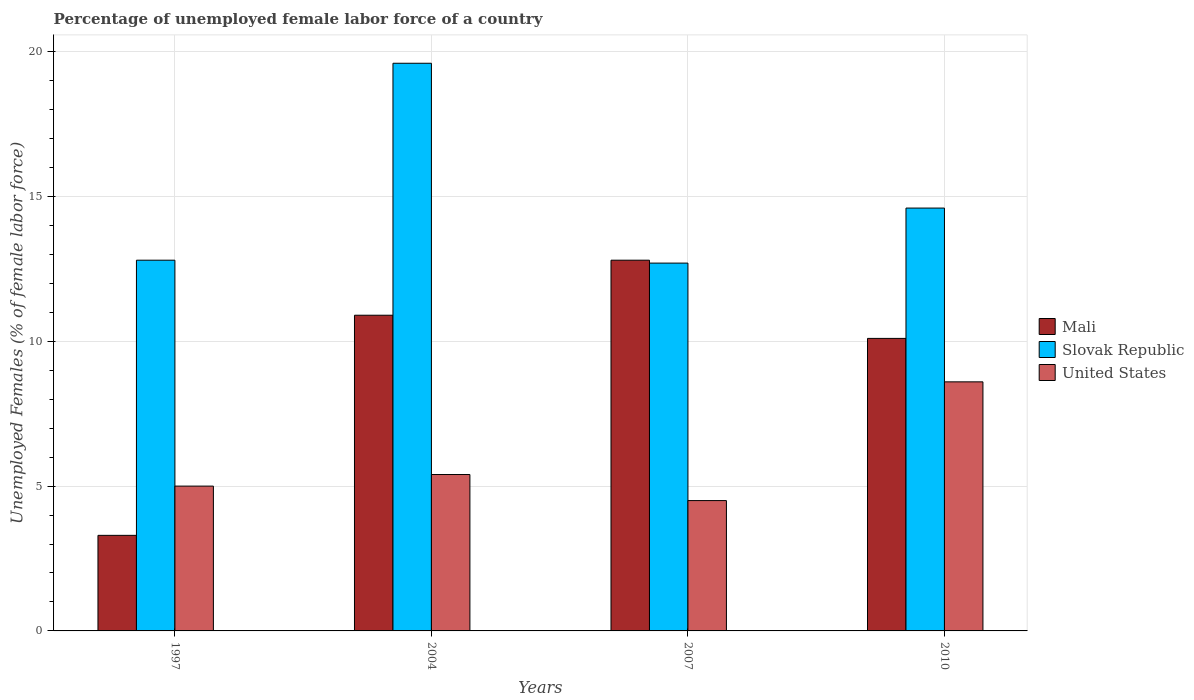How many different coloured bars are there?
Keep it short and to the point. 3. Are the number of bars on each tick of the X-axis equal?
Provide a short and direct response. Yes. How many bars are there on the 2nd tick from the right?
Offer a terse response. 3. What is the label of the 3rd group of bars from the left?
Your answer should be compact. 2007. What is the percentage of unemployed female labor force in United States in 2007?
Provide a short and direct response. 4.5. Across all years, what is the maximum percentage of unemployed female labor force in United States?
Offer a terse response. 8.6. In which year was the percentage of unemployed female labor force in Slovak Republic minimum?
Keep it short and to the point. 2007. What is the total percentage of unemployed female labor force in Slovak Republic in the graph?
Provide a short and direct response. 59.7. What is the difference between the percentage of unemployed female labor force in United States in 1997 and that in 2010?
Offer a terse response. -3.6. What is the average percentage of unemployed female labor force in Mali per year?
Keep it short and to the point. 9.28. In the year 2004, what is the difference between the percentage of unemployed female labor force in United States and percentage of unemployed female labor force in Mali?
Your answer should be very brief. -5.5. In how many years, is the percentage of unemployed female labor force in United States greater than 8 %?
Your response must be concise. 1. What is the ratio of the percentage of unemployed female labor force in Mali in 2004 to that in 2007?
Offer a very short reply. 0.85. Is the percentage of unemployed female labor force in Slovak Republic in 1997 less than that in 2010?
Ensure brevity in your answer.  Yes. What is the difference between the highest and the second highest percentage of unemployed female labor force in Slovak Republic?
Your response must be concise. 5. What is the difference between the highest and the lowest percentage of unemployed female labor force in Slovak Republic?
Offer a terse response. 6.9. In how many years, is the percentage of unemployed female labor force in United States greater than the average percentage of unemployed female labor force in United States taken over all years?
Your answer should be very brief. 1. Is the sum of the percentage of unemployed female labor force in Mali in 2004 and 2007 greater than the maximum percentage of unemployed female labor force in United States across all years?
Your answer should be very brief. Yes. What does the 2nd bar from the left in 2010 represents?
Ensure brevity in your answer.  Slovak Republic. What does the 1st bar from the right in 2010 represents?
Provide a succinct answer. United States. Is it the case that in every year, the sum of the percentage of unemployed female labor force in Mali and percentage of unemployed female labor force in Slovak Republic is greater than the percentage of unemployed female labor force in United States?
Keep it short and to the point. Yes. Does the graph contain grids?
Your response must be concise. Yes. How many legend labels are there?
Provide a succinct answer. 3. How are the legend labels stacked?
Provide a short and direct response. Vertical. What is the title of the graph?
Provide a short and direct response. Percentage of unemployed female labor force of a country. What is the label or title of the Y-axis?
Offer a very short reply. Unemployed Females (% of female labor force). What is the Unemployed Females (% of female labor force) in Mali in 1997?
Provide a short and direct response. 3.3. What is the Unemployed Females (% of female labor force) in Slovak Republic in 1997?
Offer a very short reply. 12.8. What is the Unemployed Females (% of female labor force) in Mali in 2004?
Provide a succinct answer. 10.9. What is the Unemployed Females (% of female labor force) in Slovak Republic in 2004?
Your response must be concise. 19.6. What is the Unemployed Females (% of female labor force) in United States in 2004?
Give a very brief answer. 5.4. What is the Unemployed Females (% of female labor force) in Mali in 2007?
Your answer should be very brief. 12.8. What is the Unemployed Females (% of female labor force) of Slovak Republic in 2007?
Your response must be concise. 12.7. What is the Unemployed Females (% of female labor force) in Mali in 2010?
Make the answer very short. 10.1. What is the Unemployed Females (% of female labor force) in Slovak Republic in 2010?
Provide a short and direct response. 14.6. What is the Unemployed Females (% of female labor force) of United States in 2010?
Offer a very short reply. 8.6. Across all years, what is the maximum Unemployed Females (% of female labor force) of Mali?
Keep it short and to the point. 12.8. Across all years, what is the maximum Unemployed Females (% of female labor force) of Slovak Republic?
Offer a terse response. 19.6. Across all years, what is the maximum Unemployed Females (% of female labor force) of United States?
Ensure brevity in your answer.  8.6. Across all years, what is the minimum Unemployed Females (% of female labor force) in Mali?
Your answer should be compact. 3.3. Across all years, what is the minimum Unemployed Females (% of female labor force) in Slovak Republic?
Ensure brevity in your answer.  12.7. Across all years, what is the minimum Unemployed Females (% of female labor force) in United States?
Your answer should be compact. 4.5. What is the total Unemployed Females (% of female labor force) of Mali in the graph?
Ensure brevity in your answer.  37.1. What is the total Unemployed Females (% of female labor force) in Slovak Republic in the graph?
Offer a very short reply. 59.7. What is the difference between the Unemployed Females (% of female labor force) of Mali in 1997 and that in 2004?
Make the answer very short. -7.6. What is the difference between the Unemployed Females (% of female labor force) of Slovak Republic in 1997 and that in 2004?
Give a very brief answer. -6.8. What is the difference between the Unemployed Females (% of female labor force) in United States in 1997 and that in 2004?
Your answer should be very brief. -0.4. What is the difference between the Unemployed Females (% of female labor force) of Mali in 1997 and that in 2007?
Give a very brief answer. -9.5. What is the difference between the Unemployed Females (% of female labor force) of Slovak Republic in 1997 and that in 2007?
Your response must be concise. 0.1. What is the difference between the Unemployed Females (% of female labor force) of United States in 1997 and that in 2007?
Provide a succinct answer. 0.5. What is the difference between the Unemployed Females (% of female labor force) of Mali in 1997 and that in 2010?
Make the answer very short. -6.8. What is the difference between the Unemployed Females (% of female labor force) in Slovak Republic in 1997 and that in 2010?
Make the answer very short. -1.8. What is the difference between the Unemployed Females (% of female labor force) in Mali in 2004 and that in 2007?
Your answer should be very brief. -1.9. What is the difference between the Unemployed Females (% of female labor force) of Slovak Republic in 2004 and that in 2007?
Provide a short and direct response. 6.9. What is the difference between the Unemployed Females (% of female labor force) in United States in 2004 and that in 2007?
Ensure brevity in your answer.  0.9. What is the difference between the Unemployed Females (% of female labor force) of Mali in 1997 and the Unemployed Females (% of female labor force) of Slovak Republic in 2004?
Your answer should be very brief. -16.3. What is the difference between the Unemployed Females (% of female labor force) of Mali in 1997 and the Unemployed Females (% of female labor force) of United States in 2004?
Your response must be concise. -2.1. What is the difference between the Unemployed Females (% of female labor force) in Mali in 1997 and the Unemployed Females (% of female labor force) in United States in 2007?
Your answer should be very brief. -1.2. What is the difference between the Unemployed Females (% of female labor force) of Mali in 1997 and the Unemployed Females (% of female labor force) of Slovak Republic in 2010?
Offer a very short reply. -11.3. What is the difference between the Unemployed Females (% of female labor force) in Mali in 1997 and the Unemployed Females (% of female labor force) in United States in 2010?
Make the answer very short. -5.3. What is the difference between the Unemployed Females (% of female labor force) in Mali in 2004 and the Unemployed Females (% of female labor force) in United States in 2007?
Make the answer very short. 6.4. What is the difference between the Unemployed Females (% of female labor force) in Mali in 2007 and the Unemployed Females (% of female labor force) in Slovak Republic in 2010?
Keep it short and to the point. -1.8. What is the difference between the Unemployed Females (% of female labor force) of Mali in 2007 and the Unemployed Females (% of female labor force) of United States in 2010?
Your answer should be very brief. 4.2. What is the difference between the Unemployed Females (% of female labor force) of Slovak Republic in 2007 and the Unemployed Females (% of female labor force) of United States in 2010?
Offer a very short reply. 4.1. What is the average Unemployed Females (% of female labor force) in Mali per year?
Your answer should be compact. 9.28. What is the average Unemployed Females (% of female labor force) in Slovak Republic per year?
Your answer should be very brief. 14.93. What is the average Unemployed Females (% of female labor force) in United States per year?
Your response must be concise. 5.88. In the year 1997, what is the difference between the Unemployed Females (% of female labor force) in Mali and Unemployed Females (% of female labor force) in United States?
Your response must be concise. -1.7. In the year 2004, what is the difference between the Unemployed Females (% of female labor force) of Mali and Unemployed Females (% of female labor force) of Slovak Republic?
Your response must be concise. -8.7. In the year 2007, what is the difference between the Unemployed Females (% of female labor force) in Mali and Unemployed Females (% of female labor force) in United States?
Your answer should be compact. 8.3. In the year 2007, what is the difference between the Unemployed Females (% of female labor force) in Slovak Republic and Unemployed Females (% of female labor force) in United States?
Provide a short and direct response. 8.2. In the year 2010, what is the difference between the Unemployed Females (% of female labor force) of Mali and Unemployed Females (% of female labor force) of United States?
Offer a terse response. 1.5. What is the ratio of the Unemployed Females (% of female labor force) in Mali in 1997 to that in 2004?
Your answer should be compact. 0.3. What is the ratio of the Unemployed Females (% of female labor force) in Slovak Republic in 1997 to that in 2004?
Your answer should be compact. 0.65. What is the ratio of the Unemployed Females (% of female labor force) in United States in 1997 to that in 2004?
Make the answer very short. 0.93. What is the ratio of the Unemployed Females (% of female labor force) of Mali in 1997 to that in 2007?
Offer a terse response. 0.26. What is the ratio of the Unemployed Females (% of female labor force) of Slovak Republic in 1997 to that in 2007?
Your answer should be compact. 1.01. What is the ratio of the Unemployed Females (% of female labor force) in United States in 1997 to that in 2007?
Ensure brevity in your answer.  1.11. What is the ratio of the Unemployed Females (% of female labor force) in Mali in 1997 to that in 2010?
Provide a succinct answer. 0.33. What is the ratio of the Unemployed Females (% of female labor force) in Slovak Republic in 1997 to that in 2010?
Provide a succinct answer. 0.88. What is the ratio of the Unemployed Females (% of female labor force) of United States in 1997 to that in 2010?
Provide a succinct answer. 0.58. What is the ratio of the Unemployed Females (% of female labor force) in Mali in 2004 to that in 2007?
Ensure brevity in your answer.  0.85. What is the ratio of the Unemployed Females (% of female labor force) in Slovak Republic in 2004 to that in 2007?
Give a very brief answer. 1.54. What is the ratio of the Unemployed Females (% of female labor force) of United States in 2004 to that in 2007?
Offer a very short reply. 1.2. What is the ratio of the Unemployed Females (% of female labor force) in Mali in 2004 to that in 2010?
Ensure brevity in your answer.  1.08. What is the ratio of the Unemployed Females (% of female labor force) of Slovak Republic in 2004 to that in 2010?
Your response must be concise. 1.34. What is the ratio of the Unemployed Females (% of female labor force) in United States in 2004 to that in 2010?
Keep it short and to the point. 0.63. What is the ratio of the Unemployed Females (% of female labor force) in Mali in 2007 to that in 2010?
Your answer should be very brief. 1.27. What is the ratio of the Unemployed Females (% of female labor force) in Slovak Republic in 2007 to that in 2010?
Provide a short and direct response. 0.87. What is the ratio of the Unemployed Females (% of female labor force) of United States in 2007 to that in 2010?
Provide a succinct answer. 0.52. What is the difference between the highest and the second highest Unemployed Females (% of female labor force) in Slovak Republic?
Keep it short and to the point. 5. What is the difference between the highest and the second highest Unemployed Females (% of female labor force) in United States?
Make the answer very short. 3.2. What is the difference between the highest and the lowest Unemployed Females (% of female labor force) in Mali?
Provide a short and direct response. 9.5. What is the difference between the highest and the lowest Unemployed Females (% of female labor force) of Slovak Republic?
Make the answer very short. 6.9. 